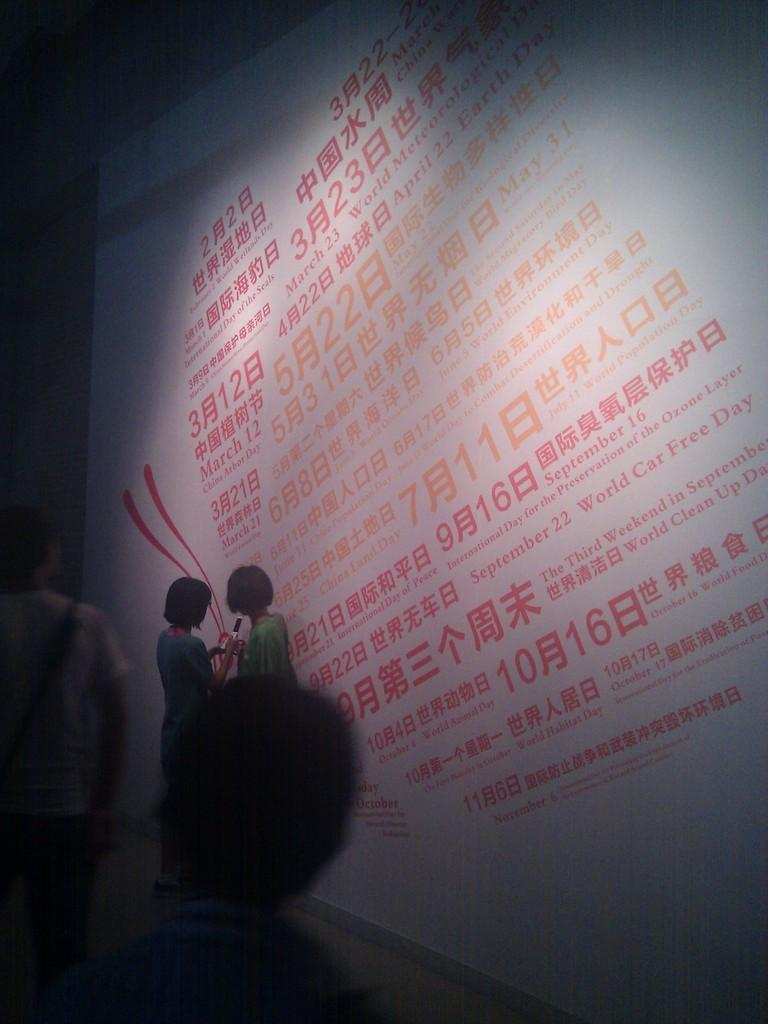How many people are in the image? The number of people in the image is not specified, but they are scattered throughout the image. What is the color of the banner in the image? The banner in the image is white. What type of club is being used by the people in the image? There is no mention of a club in the image, so it cannot be determined what type of club might be used. 